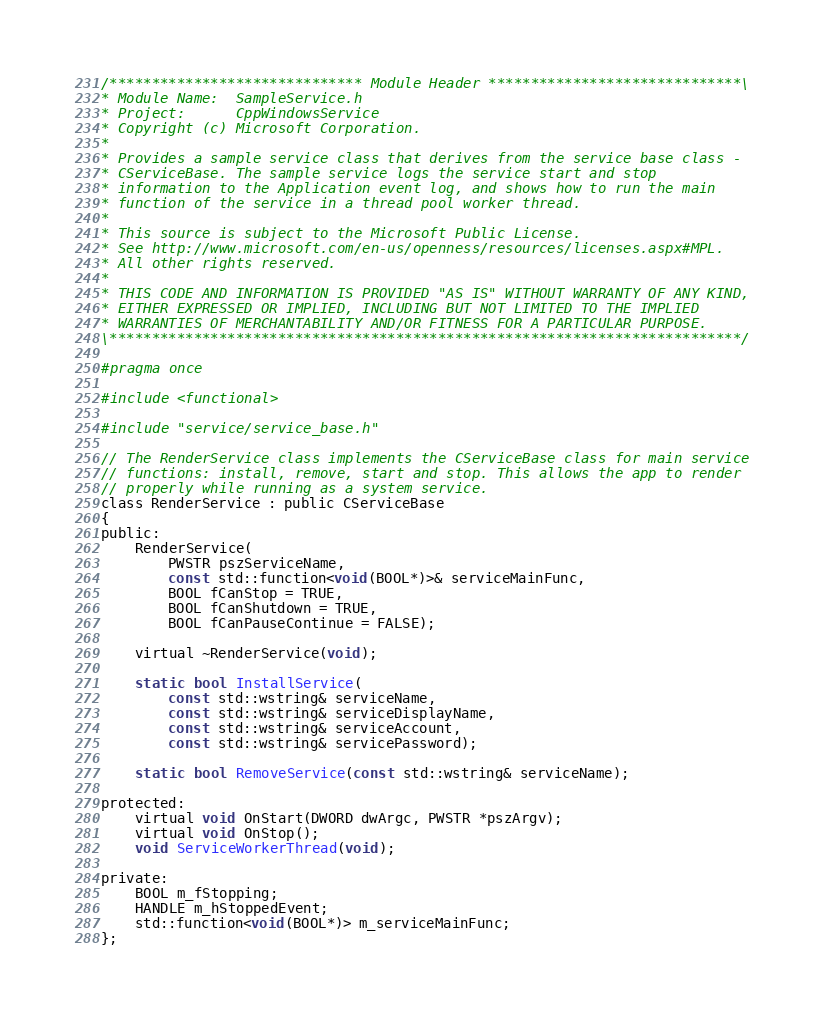Convert code to text. <code><loc_0><loc_0><loc_500><loc_500><_C_>/****************************** Module Header ******************************\
* Module Name:  SampleService.h
* Project:      CppWindowsService
* Copyright (c) Microsoft Corporation.
* 
* Provides a sample service class that derives from the service base class - 
* CServiceBase. The sample service logs the service start and stop 
* information to the Application event log, and shows how to run the main 
* function of the service in a thread pool worker thread.
* 
* This source is subject to the Microsoft Public License.
* See http://www.microsoft.com/en-us/openness/resources/licenses.aspx#MPL.
* All other rights reserved.
* 
* THIS CODE AND INFORMATION IS PROVIDED "AS IS" WITHOUT WARRANTY OF ANY KIND, 
* EITHER EXPRESSED OR IMPLIED, INCLUDING BUT NOT LIMITED TO THE IMPLIED 
* WARRANTIES OF MERCHANTABILITY AND/OR FITNESS FOR A PARTICULAR PURPOSE.
\***************************************************************************/

#pragma once

#include <functional>

#include "service/service_base.h"

// The RenderService class implements the CServiceBase class for main service
// functions: install, remove, start and stop. This allows the app to render 
// properly while running as a system service.
class RenderService : public CServiceBase
{
public:
	RenderService(
		PWSTR pszServiceName,
		const std::function<void(BOOL*)>& serviceMainFunc,
        BOOL fCanStop = TRUE, 
        BOOL fCanShutdown = TRUE, 
        BOOL fCanPauseContinue = FALSE);

    virtual ~RenderService(void);

	static bool InstallService(
		const std::wstring& serviceName,
		const std::wstring& serviceDisplayName,
		const std::wstring& serviceAccount,
		const std::wstring& servicePassword);

	static bool RemoveService(const std::wstring& serviceName);

protected:
    virtual void OnStart(DWORD dwArgc, PWSTR *pszArgv);
    virtual void OnStop();
    void ServiceWorkerThread(void);

private:
    BOOL m_fStopping;
    HANDLE m_hStoppedEvent;
	std::function<void(BOOL*)> m_serviceMainFunc;
};
</code> 